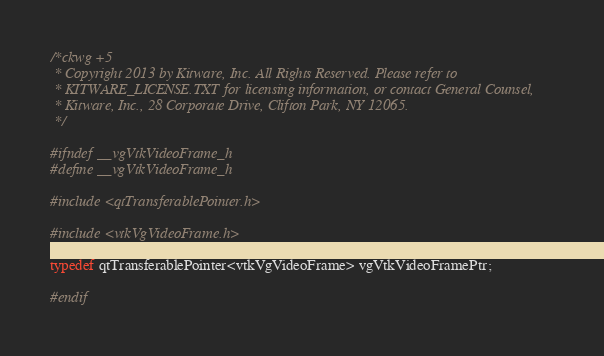Convert code to text. <code><loc_0><loc_0><loc_500><loc_500><_C_>/*ckwg +5
 * Copyright 2013 by Kitware, Inc. All Rights Reserved. Please refer to
 * KITWARE_LICENSE.TXT for licensing information, or contact General Counsel,
 * Kitware, Inc., 28 Corporate Drive, Clifton Park, NY 12065.
 */

#ifndef __vgVtkVideoFrame_h
#define __vgVtkVideoFrame_h

#include <qtTransferablePointer.h>

#include <vtkVgVideoFrame.h>

typedef qtTransferablePointer<vtkVgVideoFrame> vgVtkVideoFramePtr;

#endif
</code> 